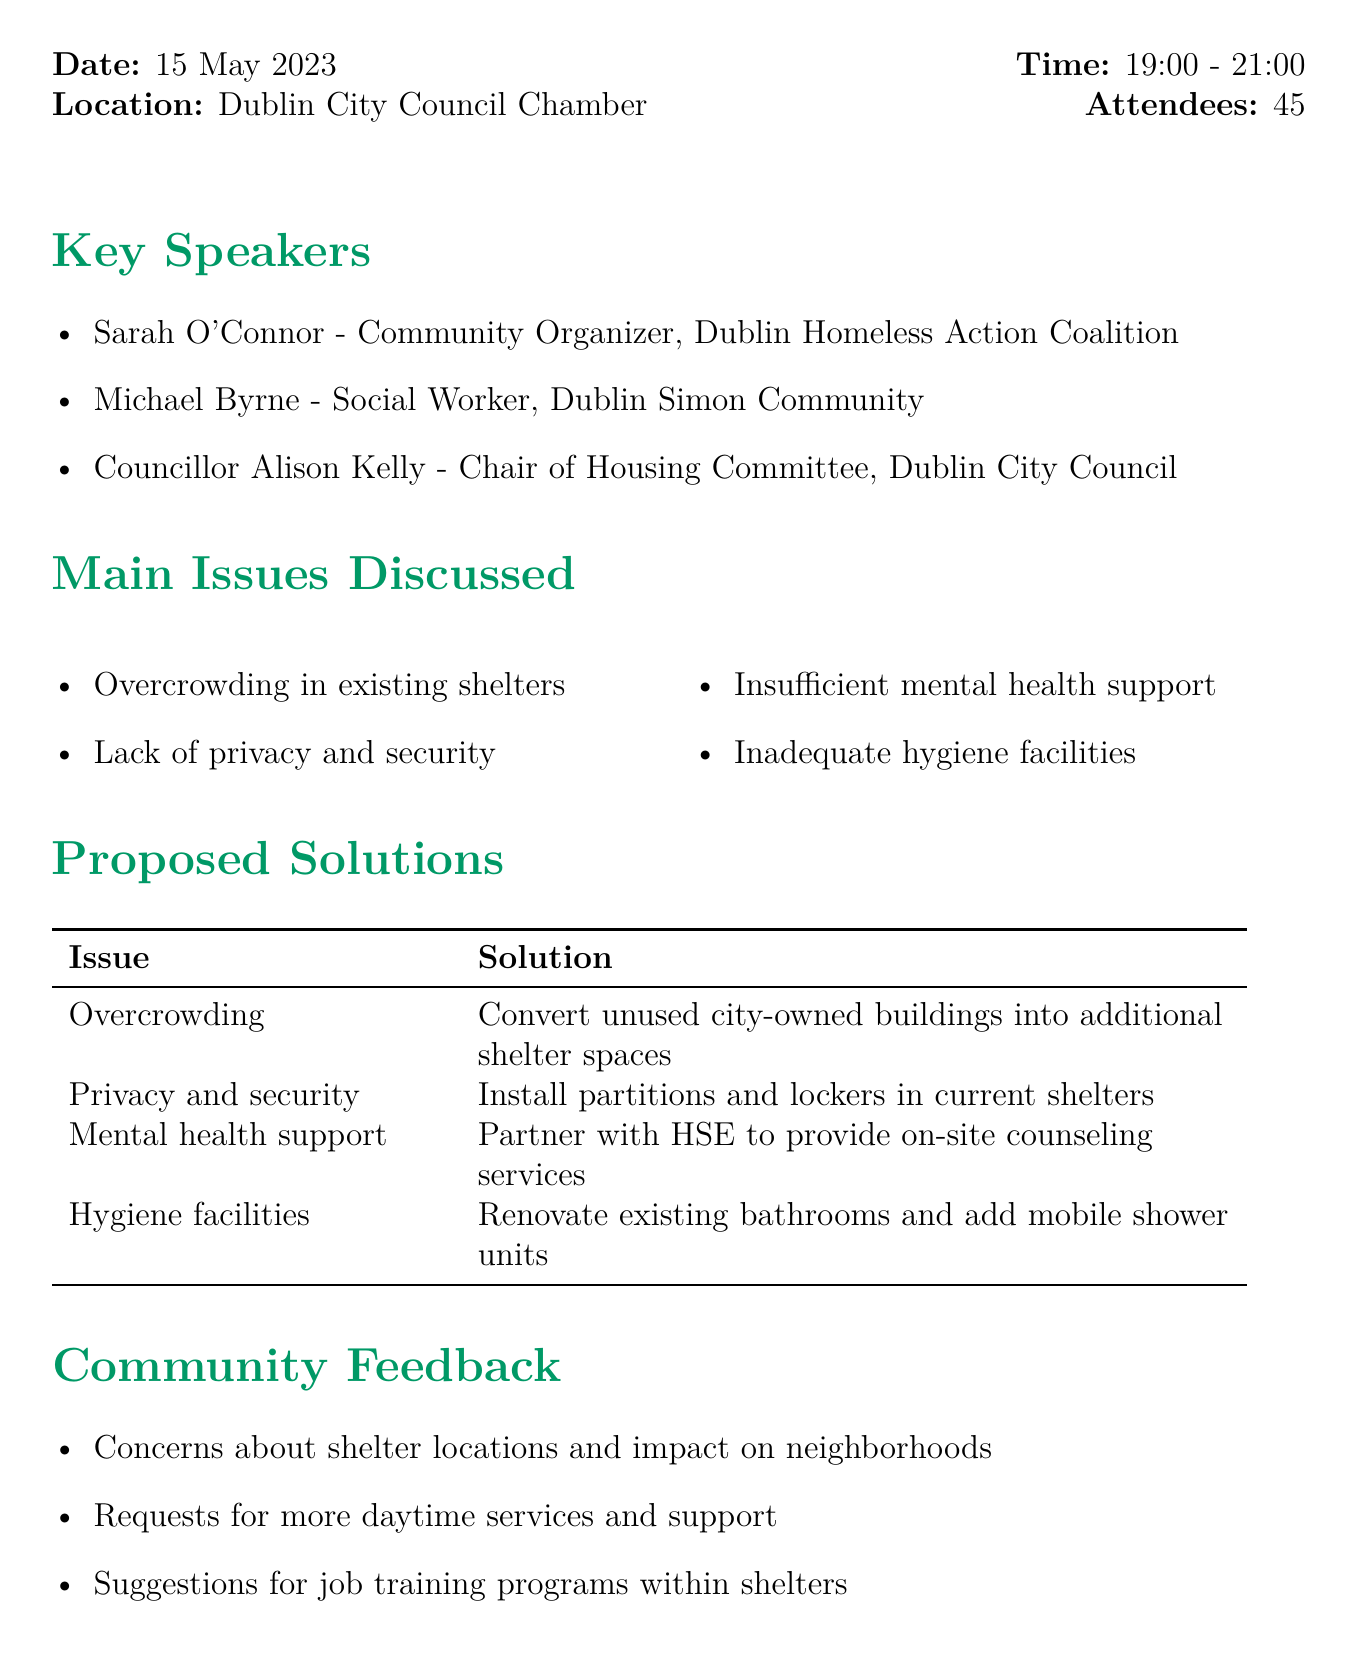What date did the meeting occur? The meeting date is specifically mentioned in the details of the document as "15 May 2023."
Answer: 15 May 2023 Who is the chair of the Housing Committee? The chair of the Housing Committee is listed among the key speakers, which is Councillor Alison Kelly.
Answer: Councillor Alison Kelly What is one of the main issues discussed? The document explicitly lists issues discussed, one of which is "Overcrowding in existing shelters."
Answer: Overcrowding in existing shelters What solution is proposed for insufficient mental health support? The proposed solution for insufficient mental health support is outlined in the document as partnering with HSE to provide on-site counseling services.
Answer: Partner with HSE to provide on-site counseling services What is the deadline for the task assigned to Sarah O'Connor? The deadline for Sarah O'Connor's task, which is drafting a proposal for City Council funding, is provided in the action items section as "1 June 2023."
Answer: 1 June 2023 How many attendees were present at the meeting? The number of attendees is specified in the meeting details as "45."
Answer: 45 What feedback was received about shelter locations? The community feedback section includes concerns about shelter locations and their impact on neighborhoods.
Answer: Concerns about shelter locations and impact on neighborhoods When is the next meeting scheduled? The next meeting date is listed in the document, noted as "12 July 2023."
Answer: 12 July 2023 